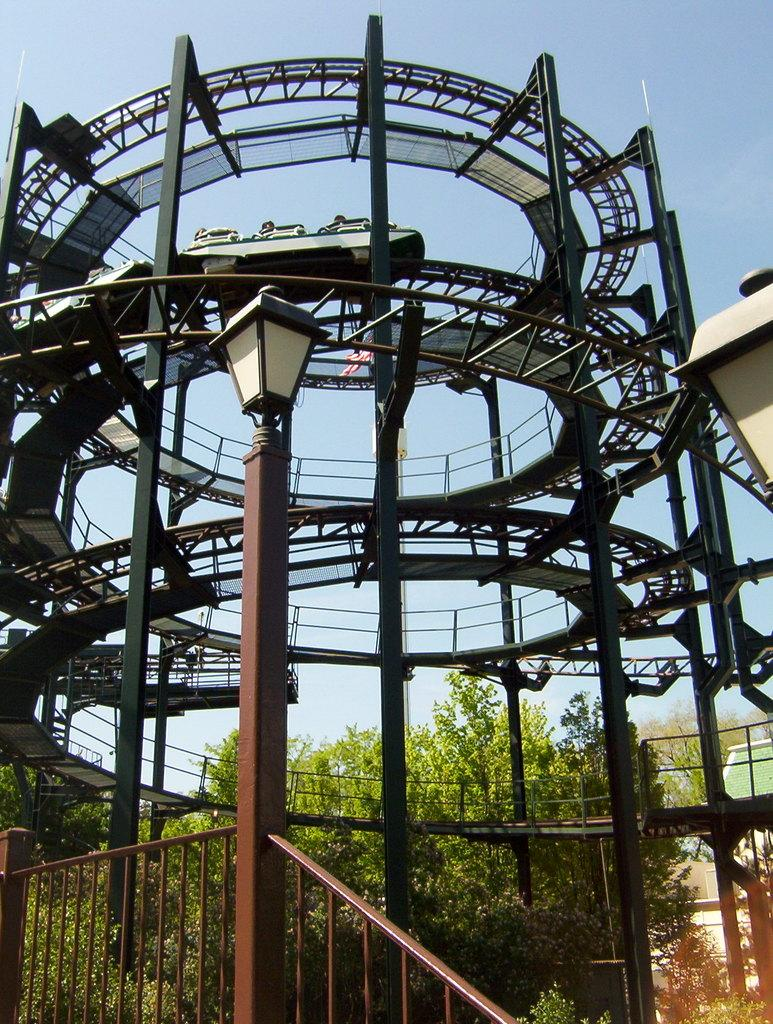What is the main object in the image? There is a pole with a light in the image. What can be seen behind the pole? There are trees behind the pole. What type of structure is visible in the image? There is an architecture tower visible in the image. What is visible in the background of the image? The sky is visible in the image. How many cables are connected to the pole in the image? There is no mention of cables connected to the pole in the image. 